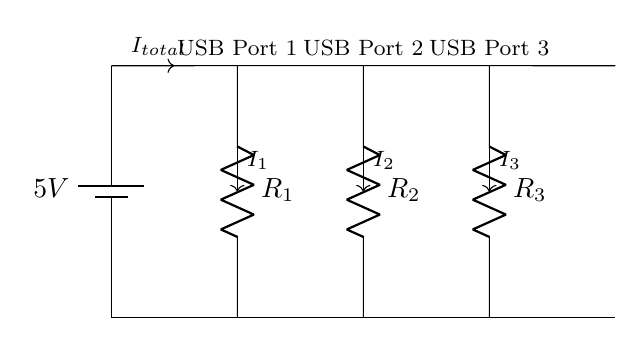What is the voltage supplied to the circuit? The circuit shows a battery labeled with a voltage of 5V at the power supply. This is the voltage supplied throughout the circuit.
Answer: 5V What do the resistors represent in this circuit? The resistors (labeled R1, R2, and R3) represent the load connected to each USB port, which could be devices drawing current when connected.
Answer: Load How many USB ports are there in this circuit? There are three designated USB ports indicated in the diagram by their labels, thus confirming the total number of ports.
Answer: Three If the total current is 10mA, what is the current going through USB Port 1? In a parallel circuit, the total current splits among the branches. If USB Port 1 is the only one connected, it receives the full 10mA.
Answer: 10mA What is the relationship between the total current and individual currents in this parallel circuit? In a parallel circuit, the total current equals the sum of all individual branch currents. Therefore, I_total = I1 + I2 + I3.
Answer: Sum Does the current through each USB port depend on the resistance connected to it? Yes, the current through each port inversely depends on the resistance connected; lower resistance allows more current to flow through that port.
Answer: Yes 